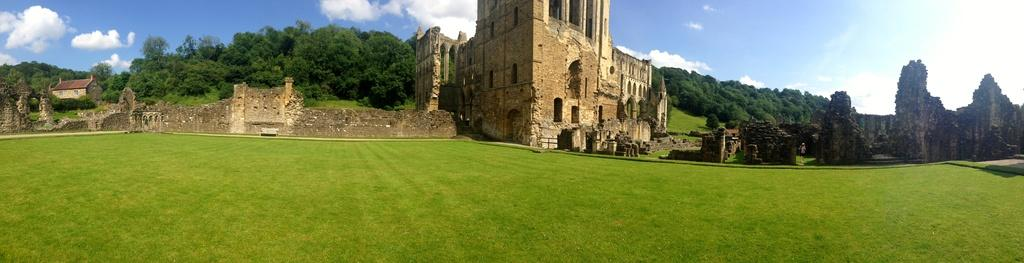What is the main structure in the image? There is a monument in the image. What can be seen in the sky in the image? The sky is visible in the image, and there are clouds in it. What type of vegetation is present in the image? There are trees in the image. Can any buildings be identified in the image? Yes, there is at least one building in the image. What is visible at the bottom of the image? The ground is visible in the image. What type of fruit is growing on the bushes in the image? There are no bushes or fruit present in the image. What account number is associated with the monument in the image? There is no account number associated with the monument in the image. 